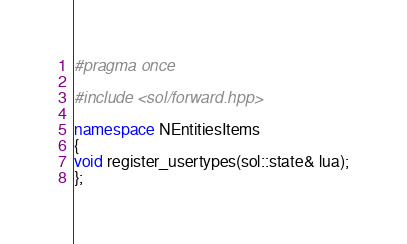<code> <loc_0><loc_0><loc_500><loc_500><_C++_>#pragma once

#include <sol/forward.hpp>

namespace NEntitiesItems
{
void register_usertypes(sol::state& lua);
};
</code> 